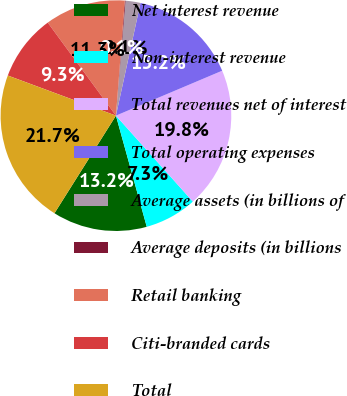Convert chart. <chart><loc_0><loc_0><loc_500><loc_500><pie_chart><fcel>Net interest revenue<fcel>Non-interest revenue<fcel>Total revenues net of interest<fcel>Total operating expenses<fcel>Average assets (in billions of<fcel>Average deposits (in billions<fcel>Retail banking<fcel>Citi-branded cards<fcel>Total<nl><fcel>13.25%<fcel>7.31%<fcel>19.75%<fcel>15.22%<fcel>2.08%<fcel>0.11%<fcel>11.29%<fcel>9.28%<fcel>21.71%<nl></chart> 